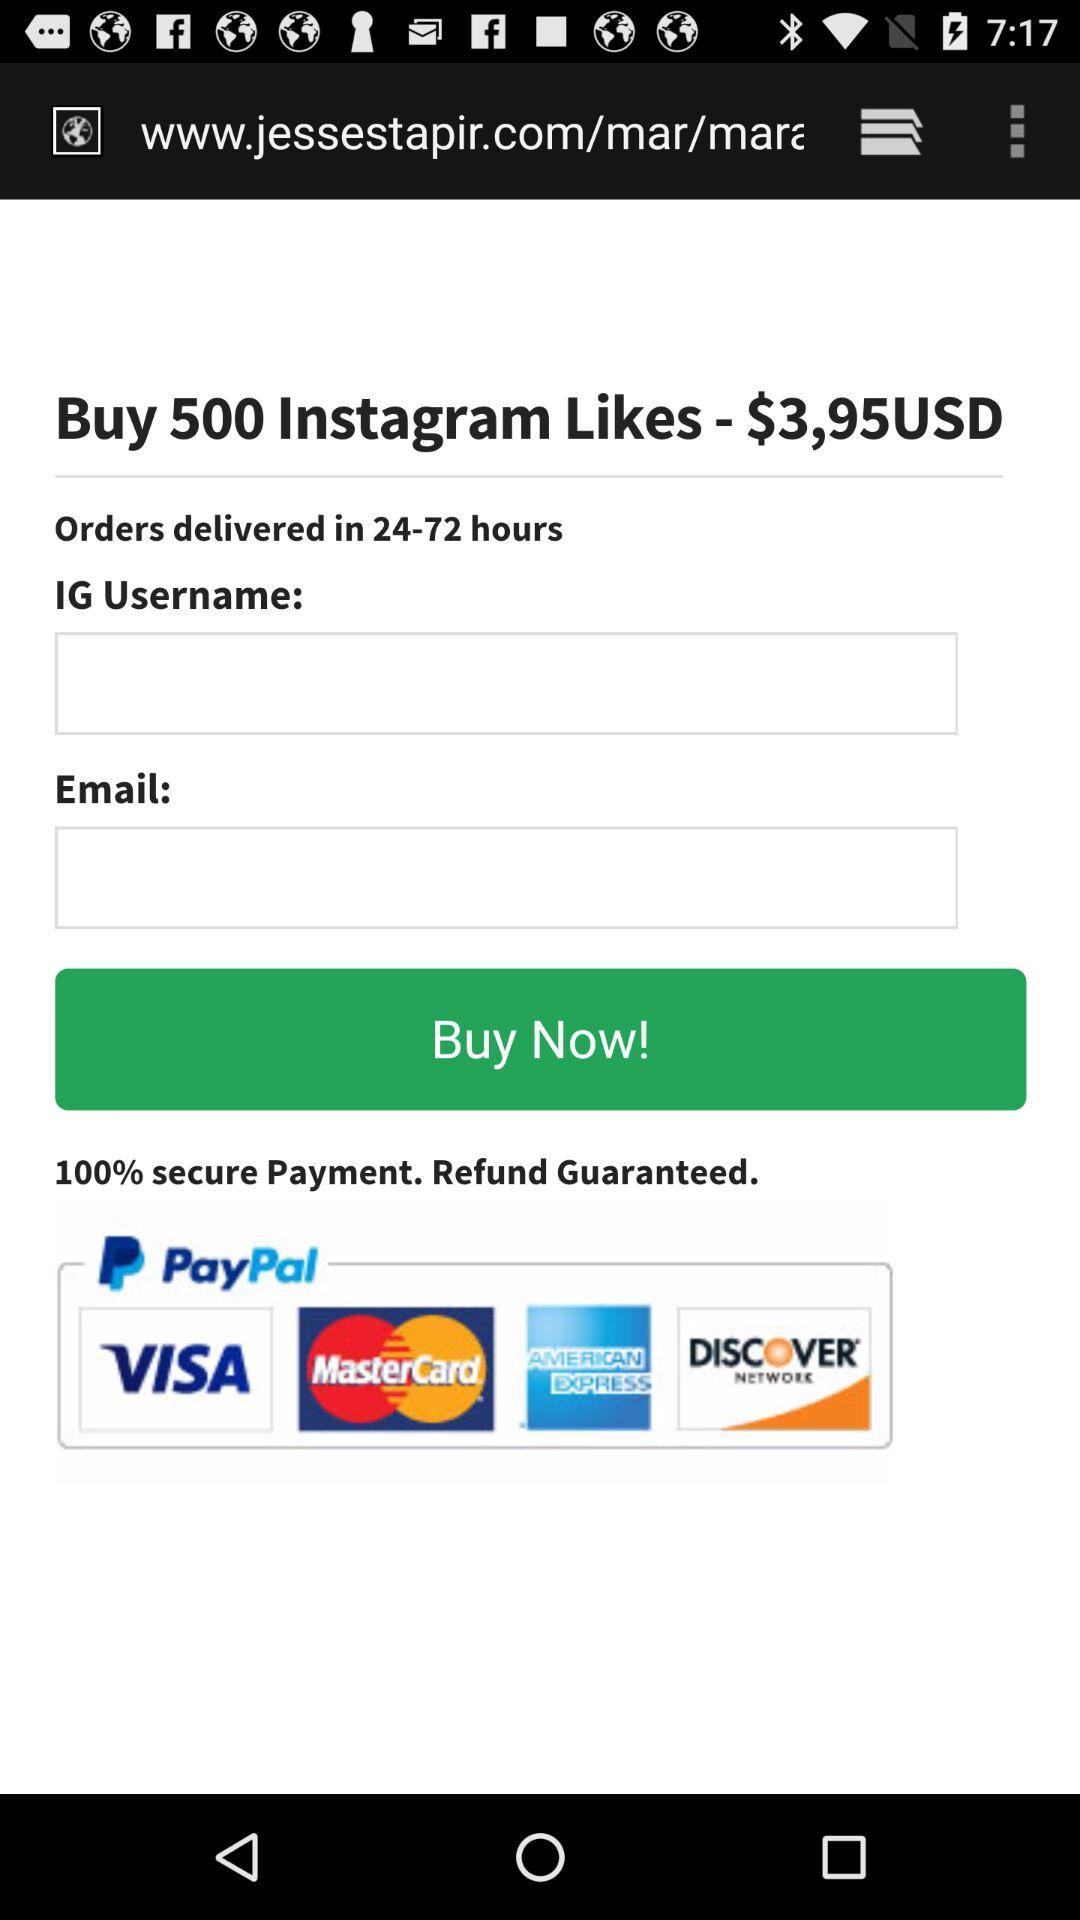What is the currency of price?
When the provided information is insufficient, respond with <no answer>. <no answer> 